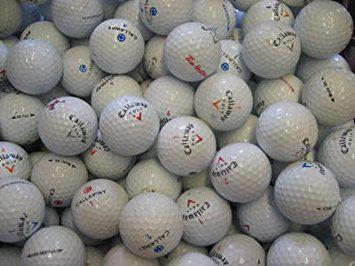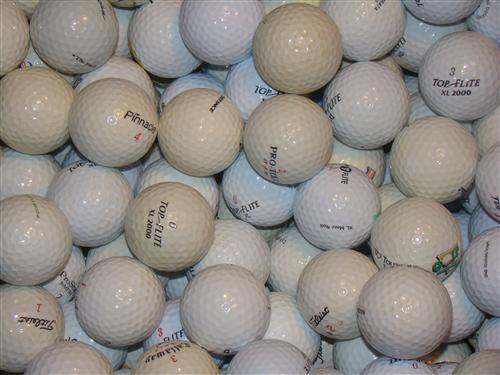The first image is the image on the left, the second image is the image on the right. For the images displayed, is the sentence "Golf balls in the left image look noticeably darker and grayer than those in the right image." factually correct? Answer yes or no. No. 